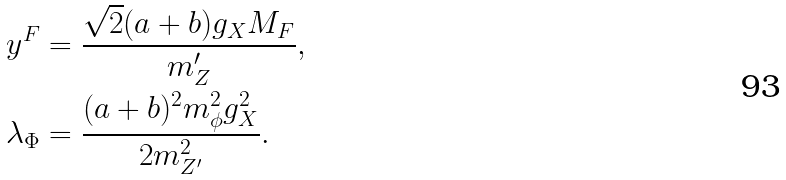Convert formula to latex. <formula><loc_0><loc_0><loc_500><loc_500>y ^ { F } & = \frac { \sqrt { 2 } ( a + b ) g _ { X } M _ { F } } { m _ { Z } ^ { \prime } } , \\ \lambda _ { \Phi } & = \frac { ( a + b ) ^ { 2 } m _ { \phi } ^ { 2 } g _ { X } ^ { 2 } } { 2 m _ { Z ^ { \prime } } ^ { 2 } } .</formula> 